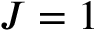Convert formula to latex. <formula><loc_0><loc_0><loc_500><loc_500>J = 1</formula> 